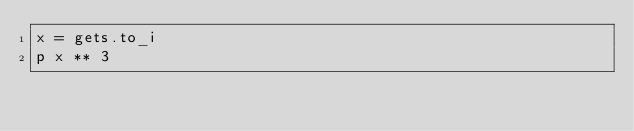Convert code to text. <code><loc_0><loc_0><loc_500><loc_500><_Ruby_>x = gets.to_i
p x ** 3
</code> 